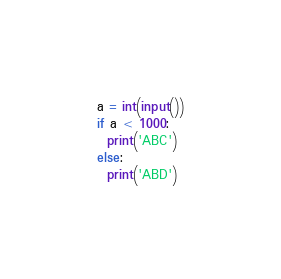Convert code to text. <code><loc_0><loc_0><loc_500><loc_500><_Python_>a = int(input())
if a < 1000:
  print('ABC')
else:
  print('ABD')</code> 